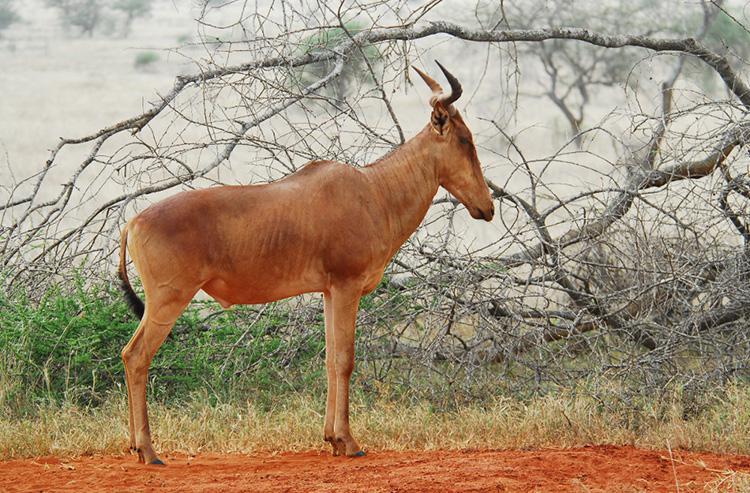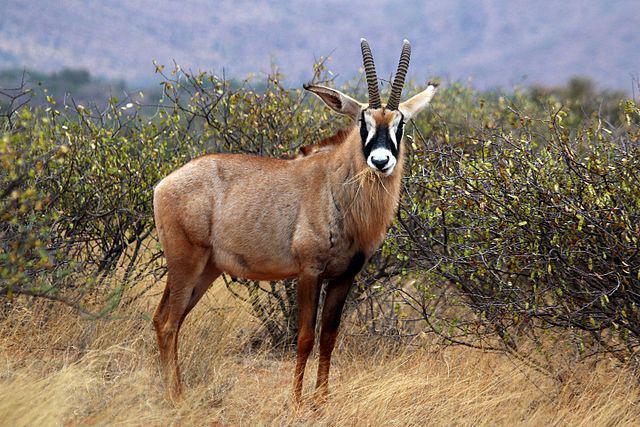The first image is the image on the left, the second image is the image on the right. Assess this claim about the two images: "Only two antelope-type animals are shown, in total.". Correct or not? Answer yes or no. Yes. 